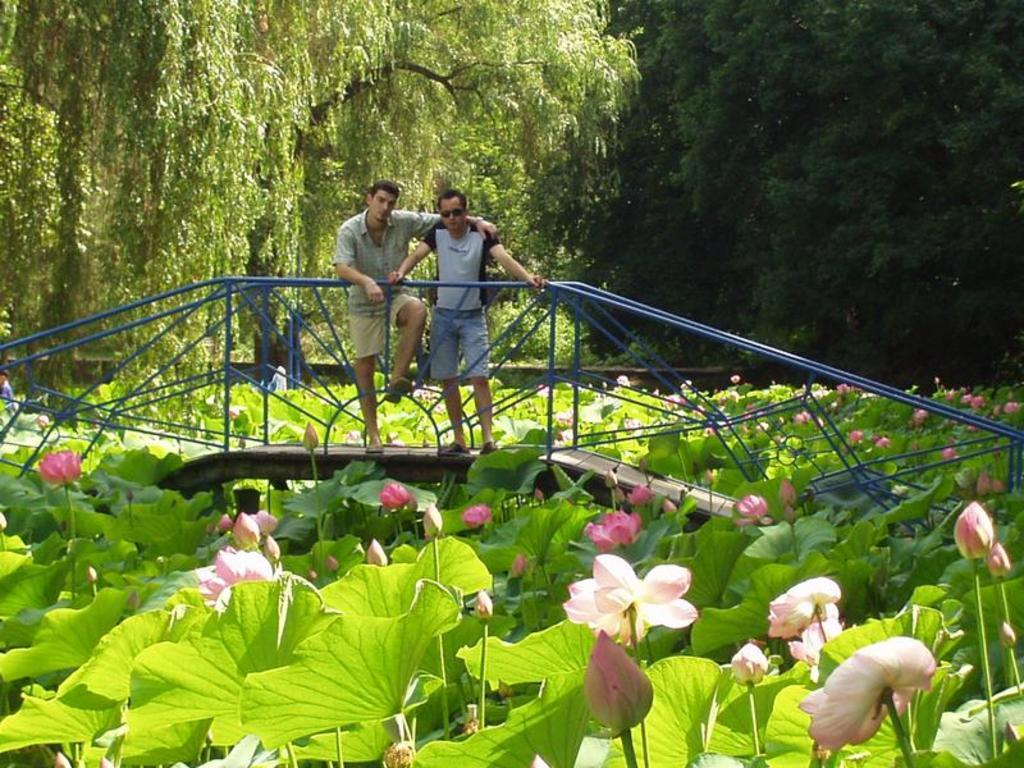How many people are in the image? There are two men in the image. Where are the men located in the image? The men are standing on a bridge. What feature does the bridge have? The bridge has railings. What is the man on the left wearing? One of the men is wearing goggles. What type of flora can be seen in the image? There are lotus flowers with plants in the image. What can be seen in the background of the image? There are trees in the background of the image. What type of books can be seen on the station in the image? There is no station or books present in the image. What country is the image taken in? The provided facts do not specify the country where the image was taken. 